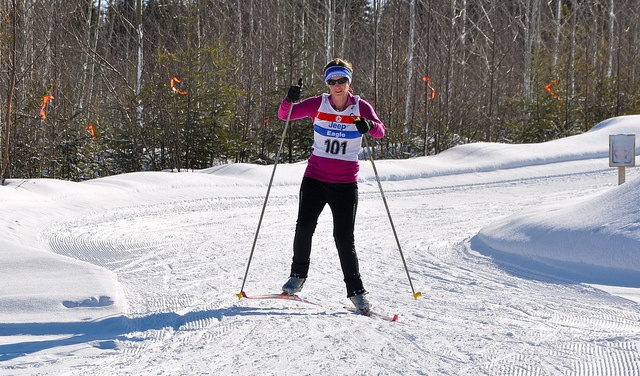Describe the objects in this image and their specific colors. I can see people in gray, black, purple, lightgray, and darkgray tones in this image. 